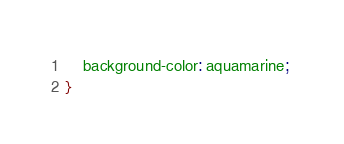<code> <loc_0><loc_0><loc_500><loc_500><_CSS_>    background-color: aquamarine; 
}</code> 